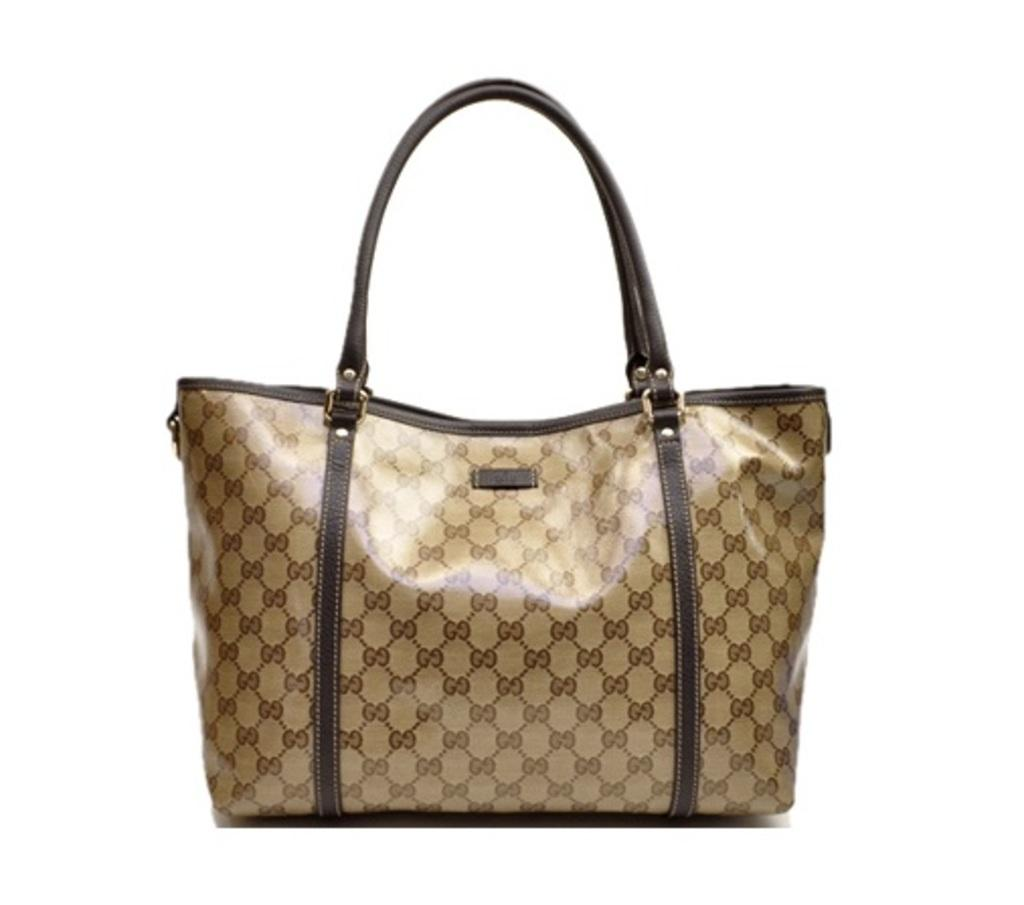What type of object is visible in the image? There is a handbag in the image. What type of soda is being poured from the handbag in the image? There is no soda present in the image; it only features a handbag. Is there a ring on the handbag in the image? The image does not provide information about any rings or accessories on the handbag. 